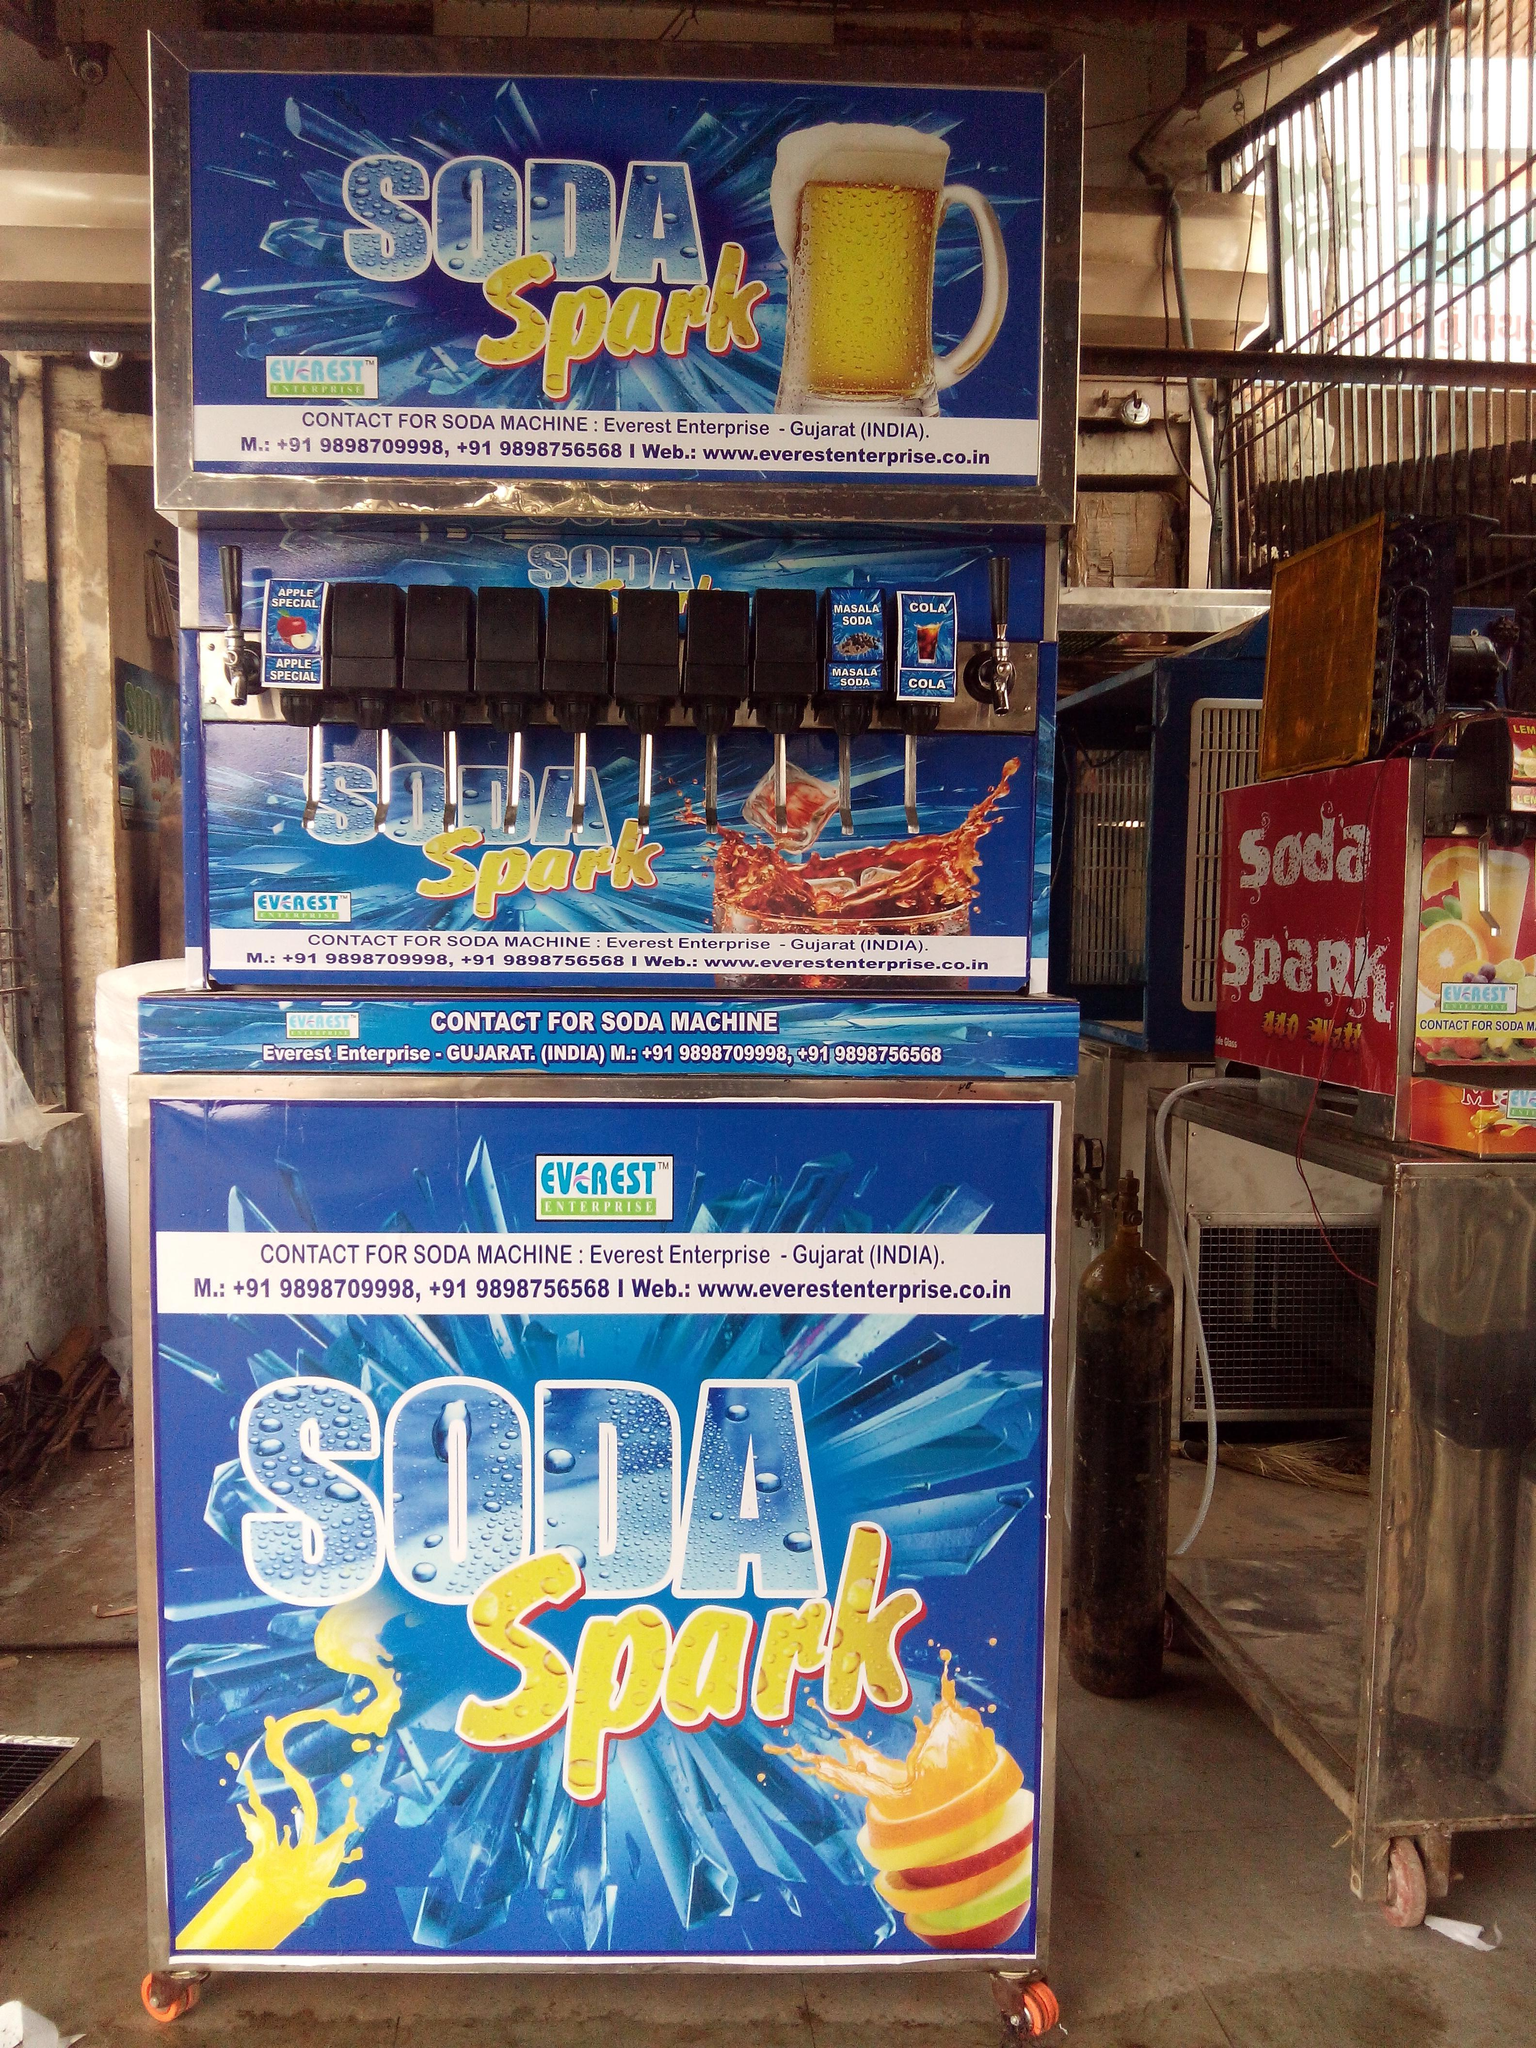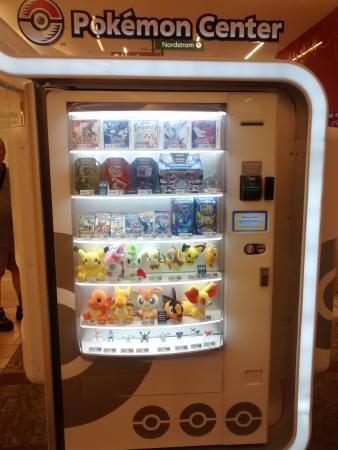The first image is the image on the left, the second image is the image on the right. Considering the images on both sides, is "Knobs can be seen beneath a single row of candies on the vending machine in one of the images." valid? Answer yes or no. No. 